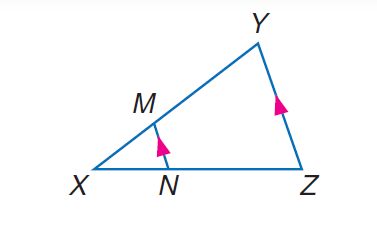Question: If X N = t - 2, N Z = t + 1, X M = 2, and X Y = 10, solve for t.
Choices:
A. 3
B. 4
C. 5
D. 8
Answer with the letter. Answer: A Question: If X M = 4, X N = 6, and N Z = 9, find X Y.
Choices:
A. 5
B. 10
C. 13
D. 15
Answer with the letter. Answer: B 